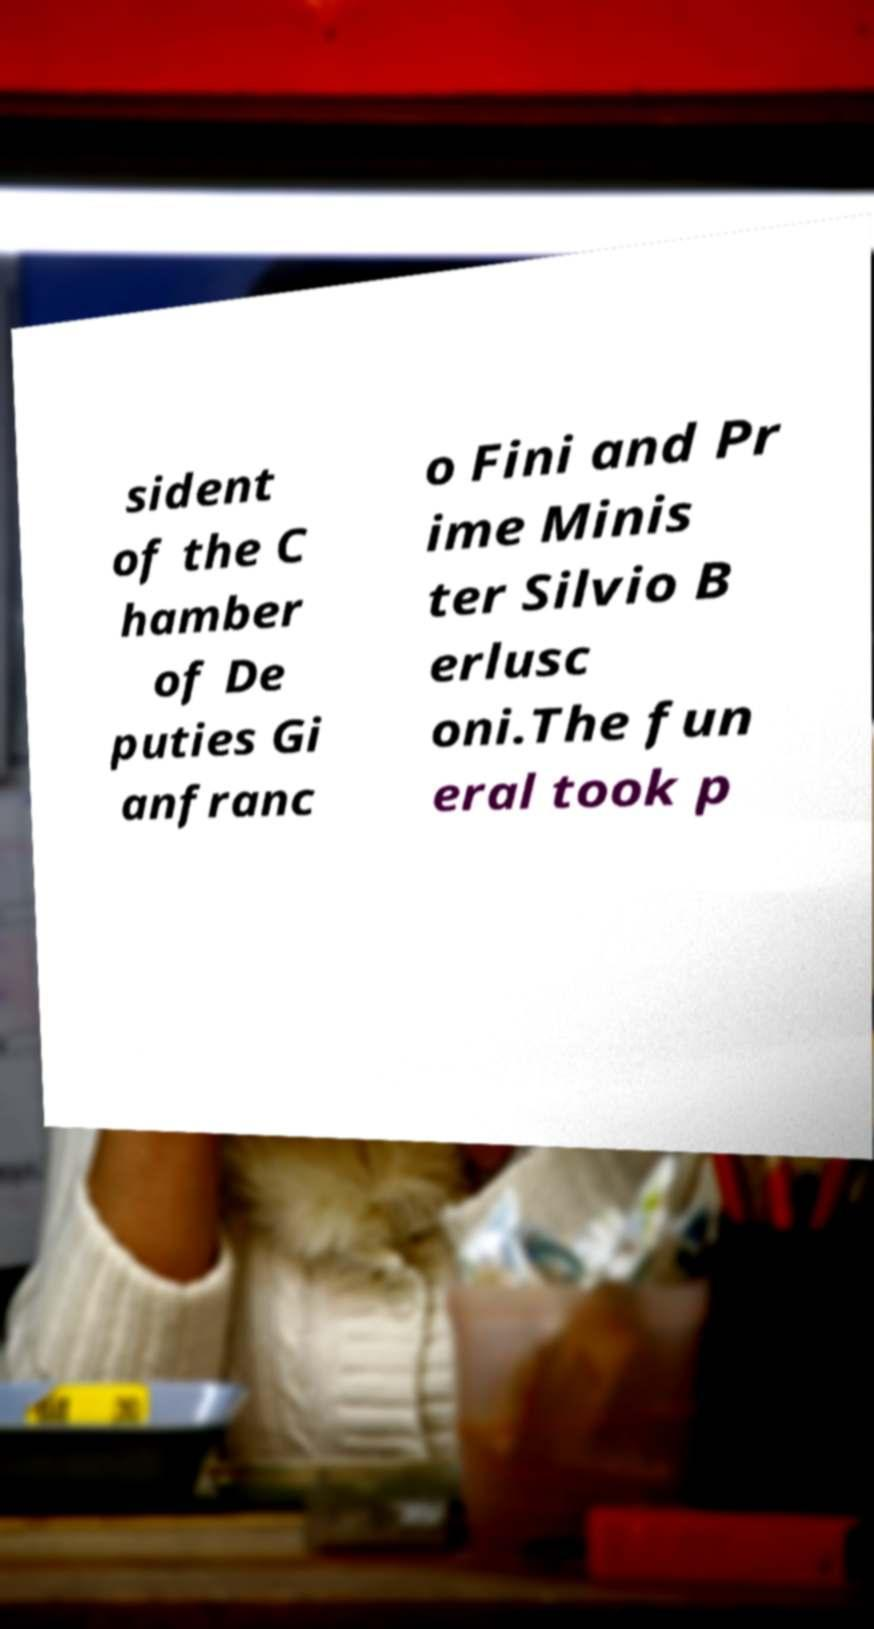Can you accurately transcribe the text from the provided image for me? sident of the C hamber of De puties Gi anfranc o Fini and Pr ime Minis ter Silvio B erlusc oni.The fun eral took p 